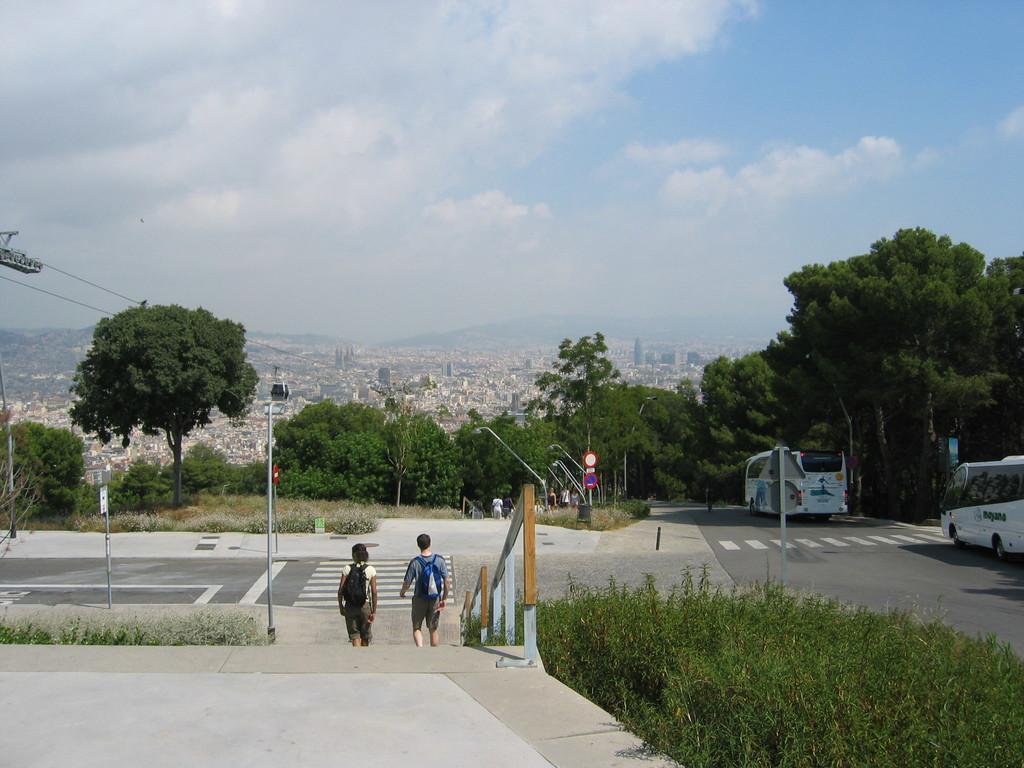Could you give a brief overview of what you see in this image? In this image I can see on the right side there are bushes, in the middle two persons are walking and there are trees. On the right side there are two vehicles on the road, at the top it is the sky. 